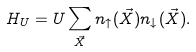Convert formula to latex. <formula><loc_0><loc_0><loc_500><loc_500>H _ { U } = U \sum _ { \vec { X } } n _ { \uparrow } ( \vec { X } ) n _ { \downarrow } ( \vec { X } ) .</formula> 